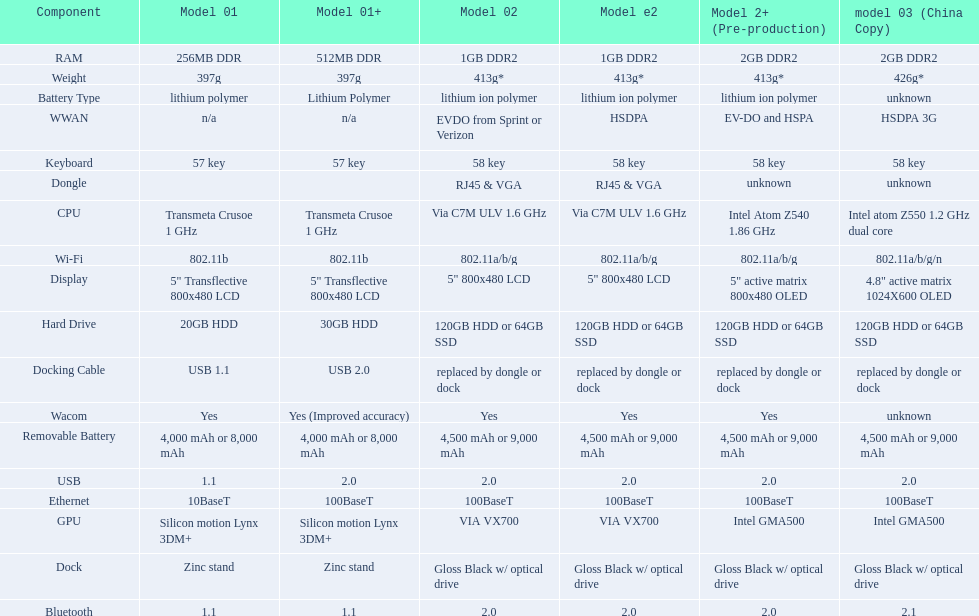Which model weighs the most, according to the table? Model 03 (china copy). 